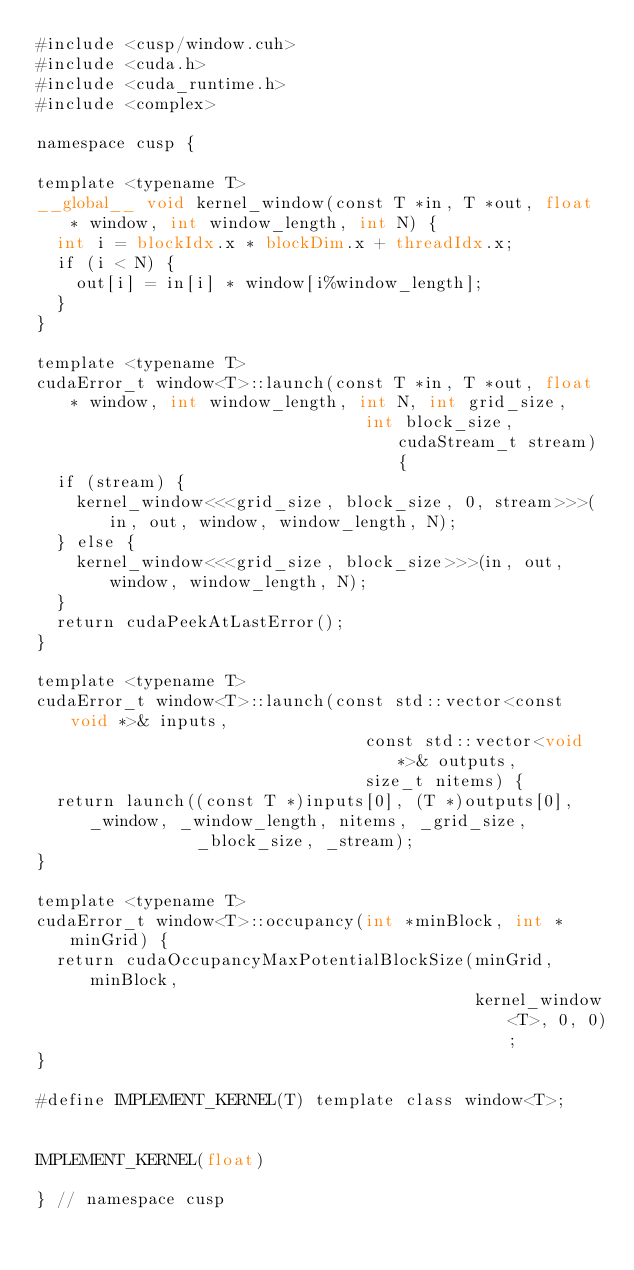<code> <loc_0><loc_0><loc_500><loc_500><_Cuda_>#include <cusp/window.cuh>
#include <cuda.h>
#include <cuda_runtime.h>
#include <complex>

namespace cusp {

template <typename T>
__global__ void kernel_window(const T *in, T *out, float * window, int window_length, int N) {
  int i = blockIdx.x * blockDim.x + threadIdx.x;
  if (i < N) {
    out[i] = in[i] * window[i%window_length];
  }
}

template <typename T>
cudaError_t window<T>::launch(const T *in, T *out, float * window, int window_length, int N, int grid_size,
                                 int block_size, cudaStream_t stream) {
  if (stream) {
    kernel_window<<<grid_size, block_size, 0, stream>>>(in, out, window, window_length, N);
  } else {
    kernel_window<<<grid_size, block_size>>>(in, out, window, window_length, N);
  }
  return cudaPeekAtLastError();
}

template <typename T>
cudaError_t window<T>::launch(const std::vector<const void *>& inputs,
                                 const std::vector<void *>& outputs,
                                 size_t nitems) {
  return launch((const T *)inputs[0], (T *)outputs[0], _window, _window_length, nitems, _grid_size,
                _block_size, _stream);
}

template <typename T>
cudaError_t window<T>::occupancy(int *minBlock, int *minGrid) {
  return cudaOccupancyMaxPotentialBlockSize(minGrid, minBlock,
                                            kernel_window<T>, 0, 0);
}

#define IMPLEMENT_KERNEL(T) template class window<T>;


IMPLEMENT_KERNEL(float)

} // namespace cusp</code> 